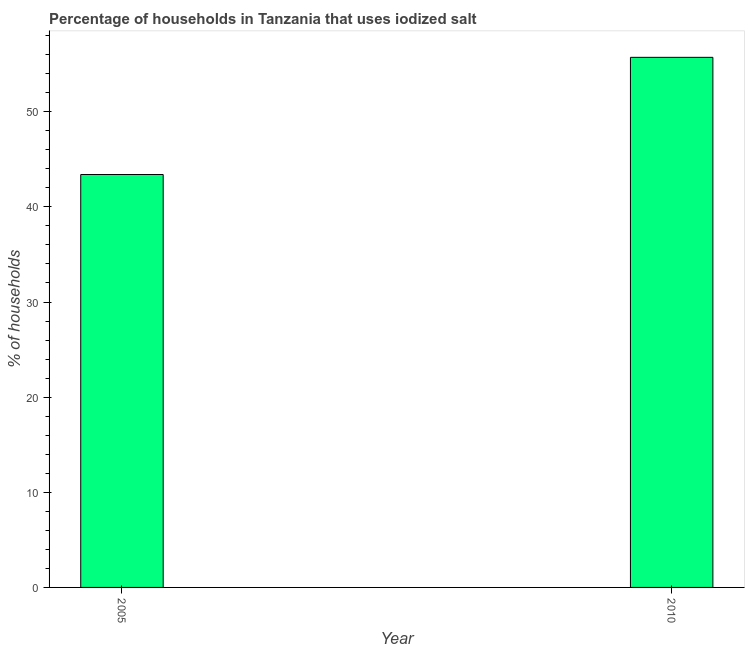What is the title of the graph?
Your answer should be compact. Percentage of households in Tanzania that uses iodized salt. What is the label or title of the X-axis?
Give a very brief answer. Year. What is the label or title of the Y-axis?
Offer a terse response. % of households. What is the percentage of households where iodized salt is consumed in 2005?
Provide a succinct answer. 43.4. Across all years, what is the maximum percentage of households where iodized salt is consumed?
Offer a very short reply. 55.72. Across all years, what is the minimum percentage of households where iodized salt is consumed?
Your answer should be compact. 43.4. What is the sum of the percentage of households where iodized salt is consumed?
Your answer should be very brief. 99.12. What is the difference between the percentage of households where iodized salt is consumed in 2005 and 2010?
Keep it short and to the point. -12.32. What is the average percentage of households where iodized salt is consumed per year?
Ensure brevity in your answer.  49.56. What is the median percentage of households where iodized salt is consumed?
Keep it short and to the point. 49.56. In how many years, is the percentage of households where iodized salt is consumed greater than 34 %?
Ensure brevity in your answer.  2. Do a majority of the years between 2010 and 2005 (inclusive) have percentage of households where iodized salt is consumed greater than 4 %?
Offer a terse response. No. What is the ratio of the percentage of households where iodized salt is consumed in 2005 to that in 2010?
Provide a succinct answer. 0.78. Are the values on the major ticks of Y-axis written in scientific E-notation?
Keep it short and to the point. No. What is the % of households in 2005?
Make the answer very short. 43.4. What is the % of households of 2010?
Keep it short and to the point. 55.72. What is the difference between the % of households in 2005 and 2010?
Your answer should be compact. -12.32. What is the ratio of the % of households in 2005 to that in 2010?
Your response must be concise. 0.78. 